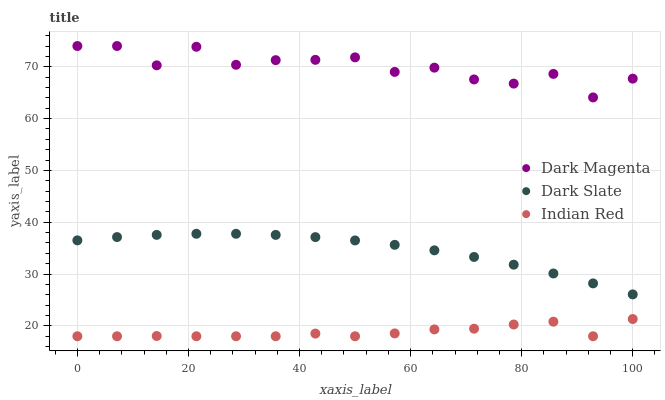Does Indian Red have the minimum area under the curve?
Answer yes or no. Yes. Does Dark Magenta have the maximum area under the curve?
Answer yes or no. Yes. Does Dark Magenta have the minimum area under the curve?
Answer yes or no. No. Does Indian Red have the maximum area under the curve?
Answer yes or no. No. Is Dark Slate the smoothest?
Answer yes or no. Yes. Is Dark Magenta the roughest?
Answer yes or no. Yes. Is Indian Red the smoothest?
Answer yes or no. No. Is Indian Red the roughest?
Answer yes or no. No. Does Indian Red have the lowest value?
Answer yes or no. Yes. Does Dark Magenta have the lowest value?
Answer yes or no. No. Does Dark Magenta have the highest value?
Answer yes or no. Yes. Does Indian Red have the highest value?
Answer yes or no. No. Is Indian Red less than Dark Magenta?
Answer yes or no. Yes. Is Dark Magenta greater than Dark Slate?
Answer yes or no. Yes. Does Indian Red intersect Dark Magenta?
Answer yes or no. No. 